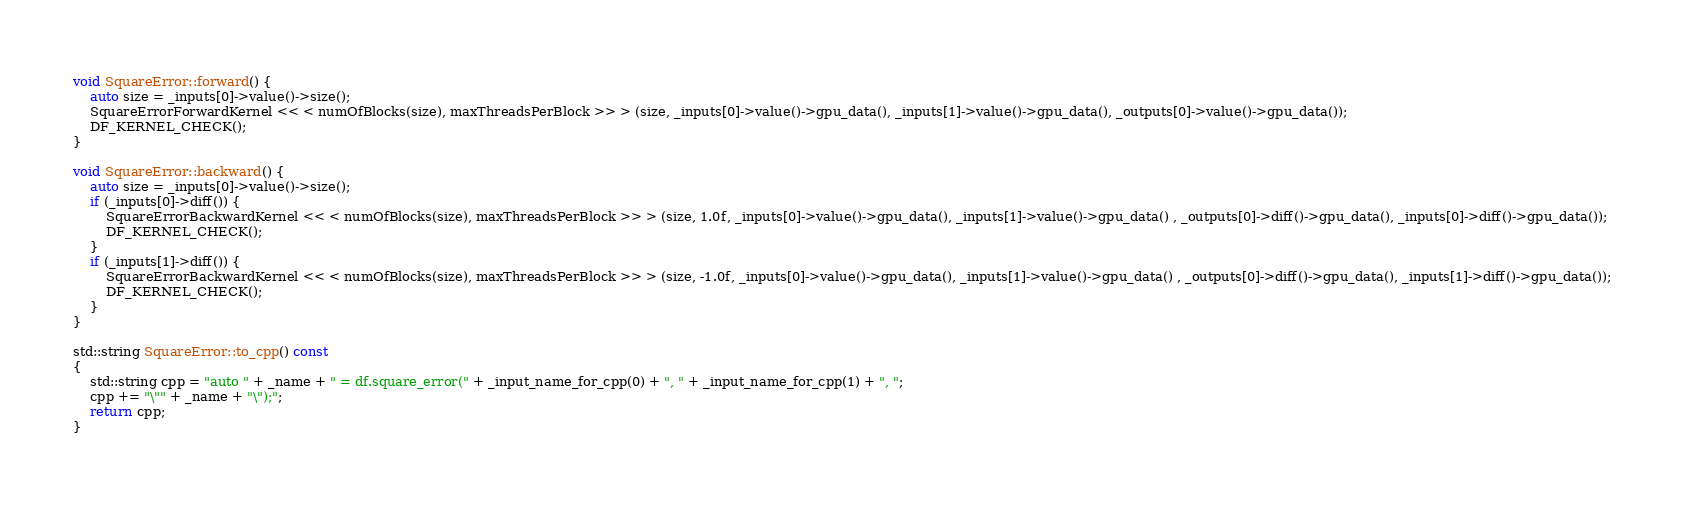<code> <loc_0><loc_0><loc_500><loc_500><_Cuda_>
void SquareError::forward() {
	auto size = _inputs[0]->value()->size();
	SquareErrorForwardKernel << < numOfBlocks(size), maxThreadsPerBlock >> > (size, _inputs[0]->value()->gpu_data(), _inputs[1]->value()->gpu_data(), _outputs[0]->value()->gpu_data());
	DF_KERNEL_CHECK();
}

void SquareError::backward() {
	auto size = _inputs[0]->value()->size();
	if (_inputs[0]->diff()) {
		SquareErrorBackwardKernel << < numOfBlocks(size), maxThreadsPerBlock >> > (size, 1.0f, _inputs[0]->value()->gpu_data(), _inputs[1]->value()->gpu_data() , _outputs[0]->diff()->gpu_data(), _inputs[0]->diff()->gpu_data());
		DF_KERNEL_CHECK();
	}
	if (_inputs[1]->diff()) {
		SquareErrorBackwardKernel << < numOfBlocks(size), maxThreadsPerBlock >> > (size, -1.0f, _inputs[0]->value()->gpu_data(), _inputs[1]->value()->gpu_data() , _outputs[0]->diff()->gpu_data(), _inputs[1]->diff()->gpu_data());
		DF_KERNEL_CHECK();
	}
}

std::string SquareError::to_cpp() const
{
	std::string cpp = "auto " + _name + " = df.square_error(" + _input_name_for_cpp(0) + ", " + _input_name_for_cpp(1) + ", ";
	cpp += "\"" + _name + "\");";	
	return cpp;
}
</code> 